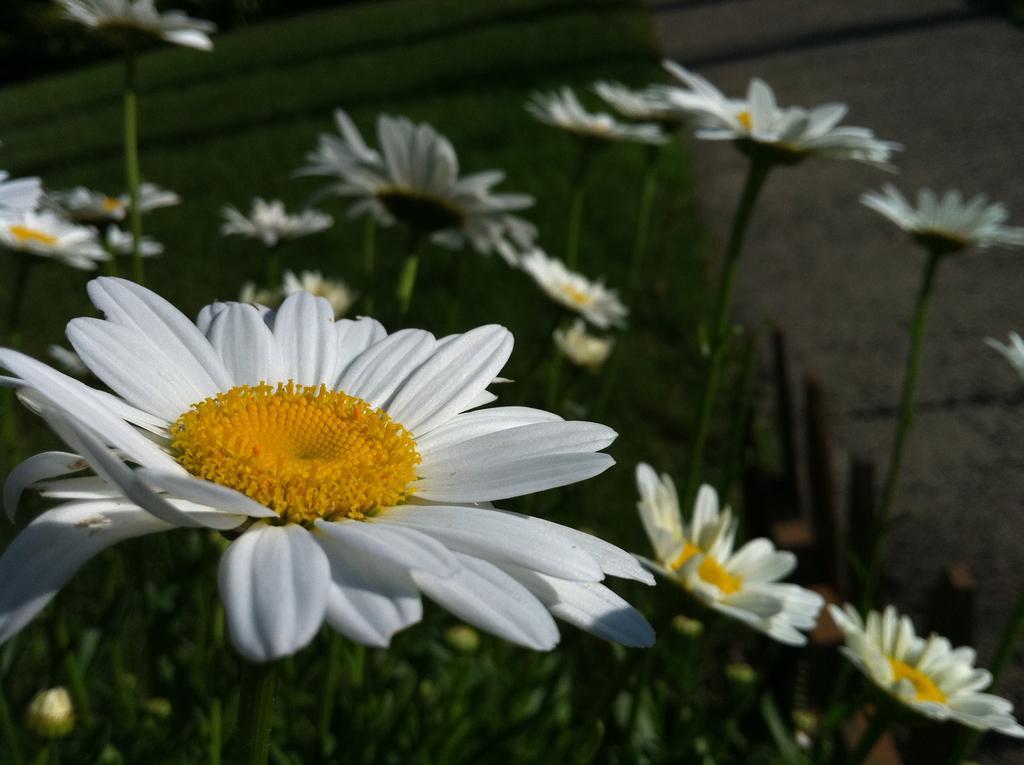Please provide a concise description of this image. In this image on the left, there is a flower. In the background there are plants and flowers. 